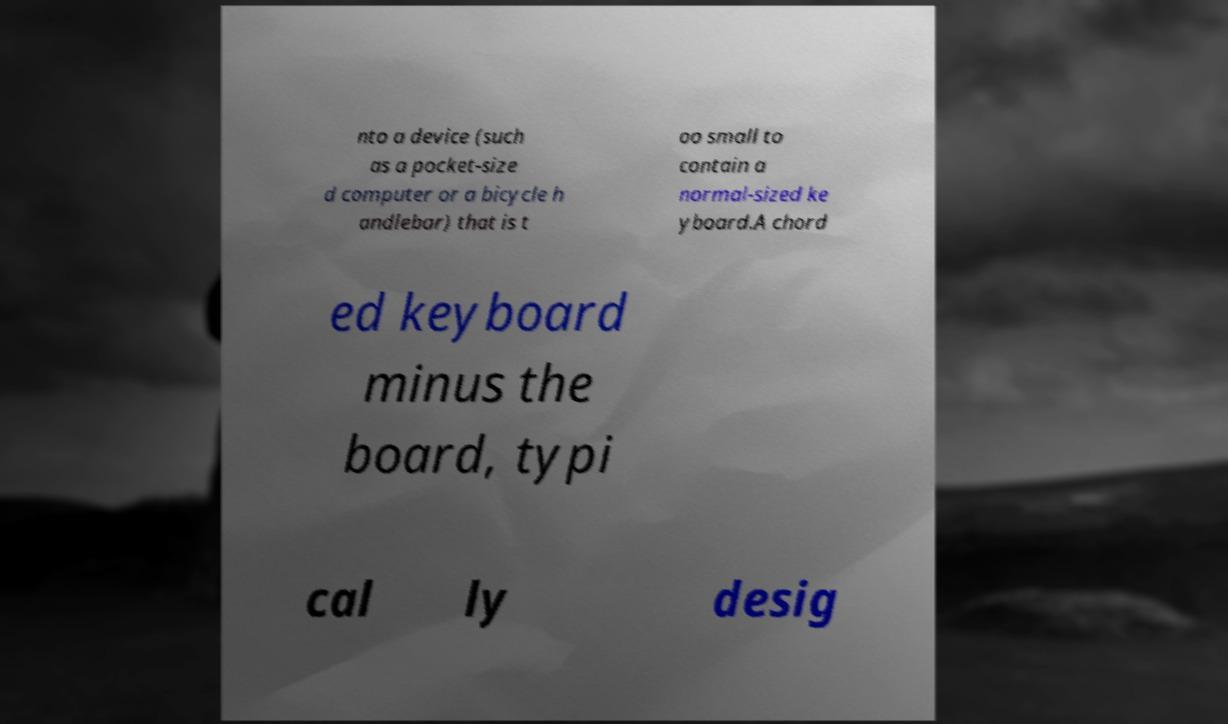Can you read and provide the text displayed in the image?This photo seems to have some interesting text. Can you extract and type it out for me? nto a device (such as a pocket-size d computer or a bicycle h andlebar) that is t oo small to contain a normal-sized ke yboard.A chord ed keyboard minus the board, typi cal ly desig 